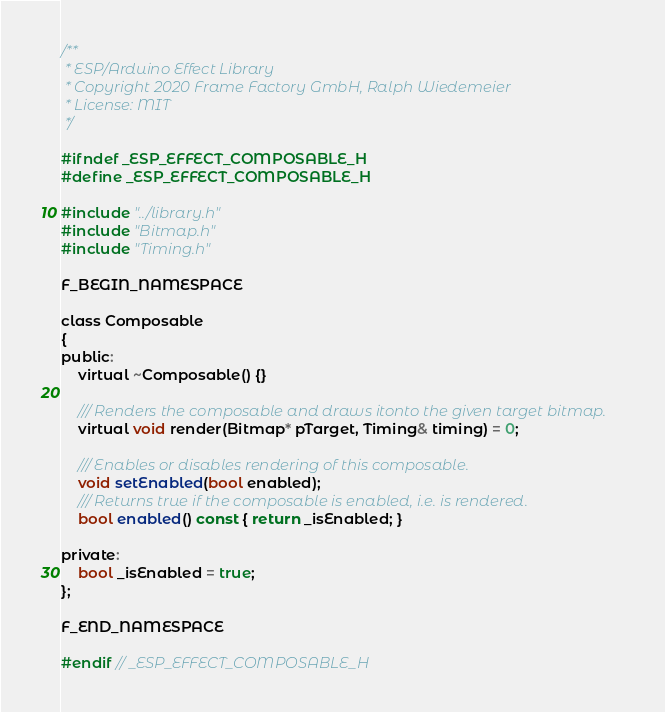<code> <loc_0><loc_0><loc_500><loc_500><_C_>/**
 * ESP/Arduino Effect Library
 * Copyright 2020 Frame Factory GmbH, Ralph Wiedemeier
 * License: MIT
 */

#ifndef _ESP_EFFECT_COMPOSABLE_H
#define _ESP_EFFECT_COMPOSABLE_H

#include "../library.h"
#include "Bitmap.h"
#include "Timing.h"

F_BEGIN_NAMESPACE

class Composable
{
public:
    virtual ~Composable() {}

    /// Renders the composable and draws itonto the given target bitmap.
    virtual void render(Bitmap* pTarget, Timing& timing) = 0;

    /// Enables or disables rendering of this composable.
    void setEnabled(bool enabled);
    /// Returns true if the composable is enabled, i.e. is rendered.
    bool enabled() const { return _isEnabled; }

private:
    bool _isEnabled = true;
};

F_END_NAMESPACE

#endif // _ESP_EFFECT_COMPOSABLE_H</code> 